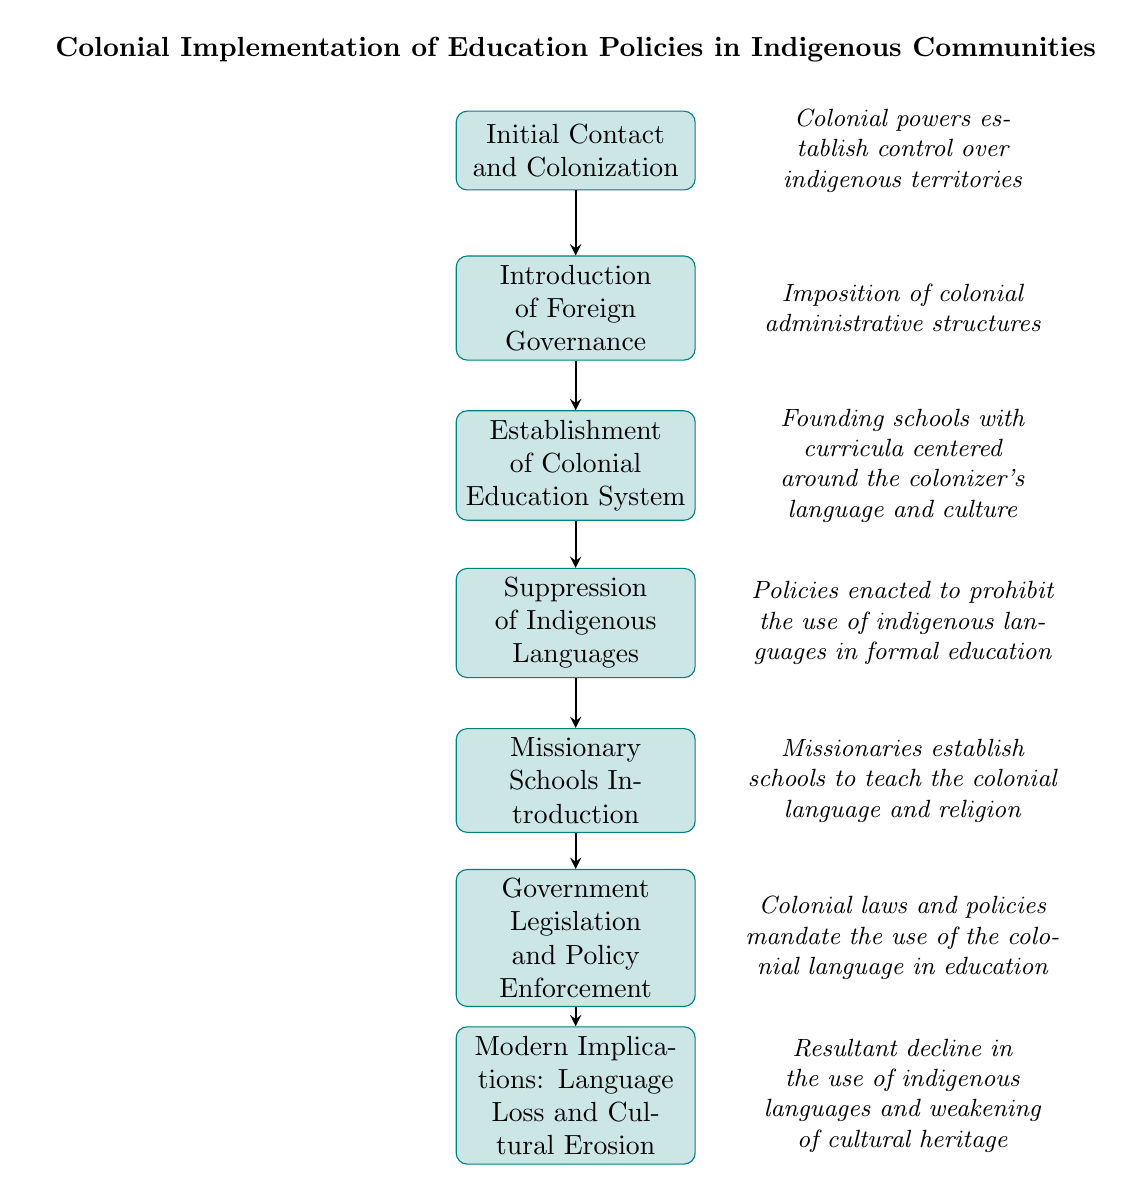What is the first step in the flowchart? The first node in the flowchart is labeled "Initial Contact and Colonization," indicating the starting point of the process depicted.
Answer: Initial Contact and Colonization How many nodes are in the diagram? The diagram contains a total of seven nodes, each representing a distinct step in the process of colonial education implementation.
Answer: 7 What action is depicted between 'Establishment of Colonial Education System' and 'Suppression of Indigenous Languages'? The flowchart shows a directed relationship where the establishment of the colonial education system directly leads to the suppression of indigenous languages, implying a sequential action.
Answer: Suppression of Indigenous Languages Which node introduces missionary schools? The node labeled "Missionary Schools Introduction" directly follows the suppression of indigenous languages, indicating that this step is related to education through religious institutions.
Answer: Missionary Schools Introduction What is the final implication of the policies outlined in the flowchart? The last node states "Modern Implications: Language Loss and Cultural Erosion," summarizing the long-term consequences of the historical education policies on indigenous cultures.
Answer: Language Loss and Cultural Erosion How do governmental policies affect language in the educational context? According to the flowchart, "Government Legislation and Policy Enforcement" mandates the use of the colonial language in education, directly shaping the language landscape within these institutions.
Answer: Mandate the use of the colonial language What precedes 'Missionary Schools Introduction' in the flowchart? The flowchart shows that the step immediately before the "Missionary Schools Introduction" is "Suppression of Indigenous Languages," indicating a causal link between the suppression and the establishment of these schools.
Answer: Suppression of Indigenous Languages Which steps depict the progression of education policy from colonial introduction to modern implications? The flowchart illustrates a linear progression starting from "Initial Contact and Colonization" through various steps ending at "Modern Implications: Language Loss and Cultural Erosion," showing how each step influences the next.
Answer: From Initial Contact and Colonization to Modern Implications 